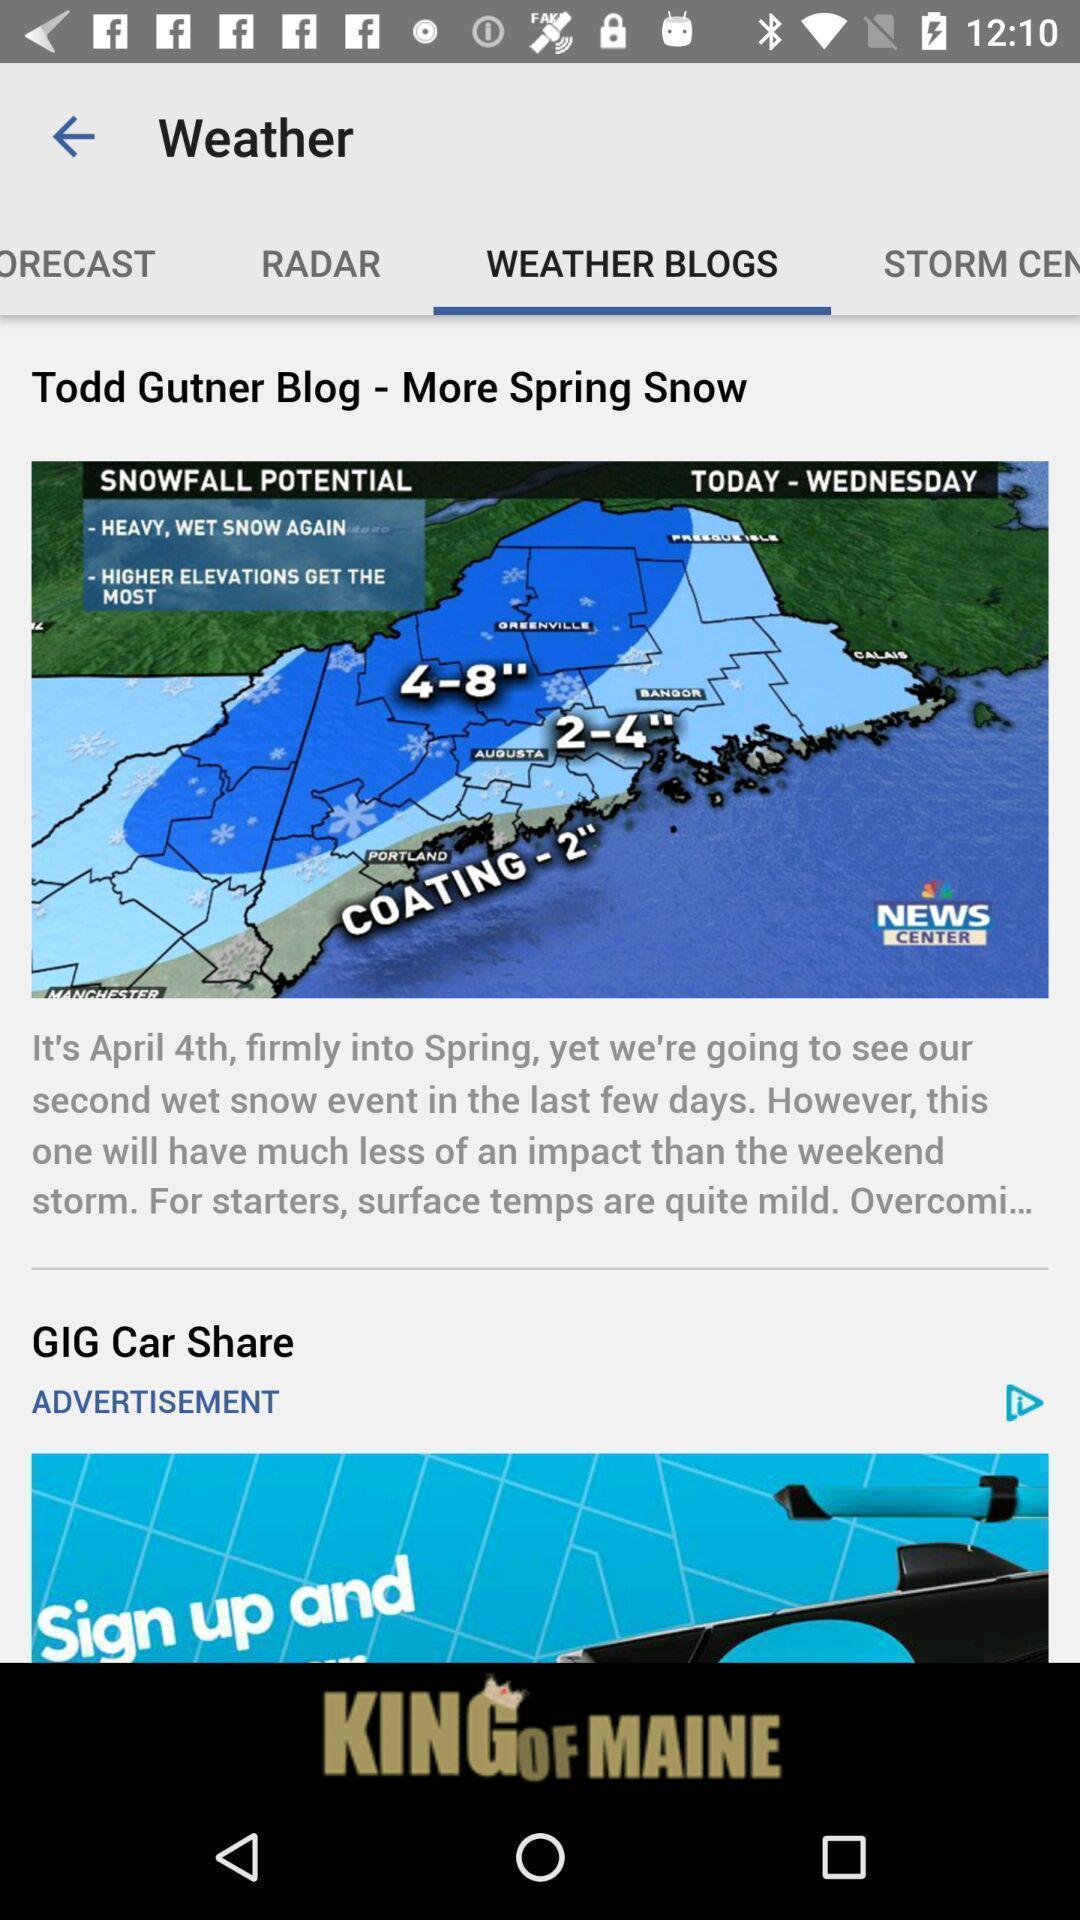Describe this image in words. Page with weather blogs in a news app. 